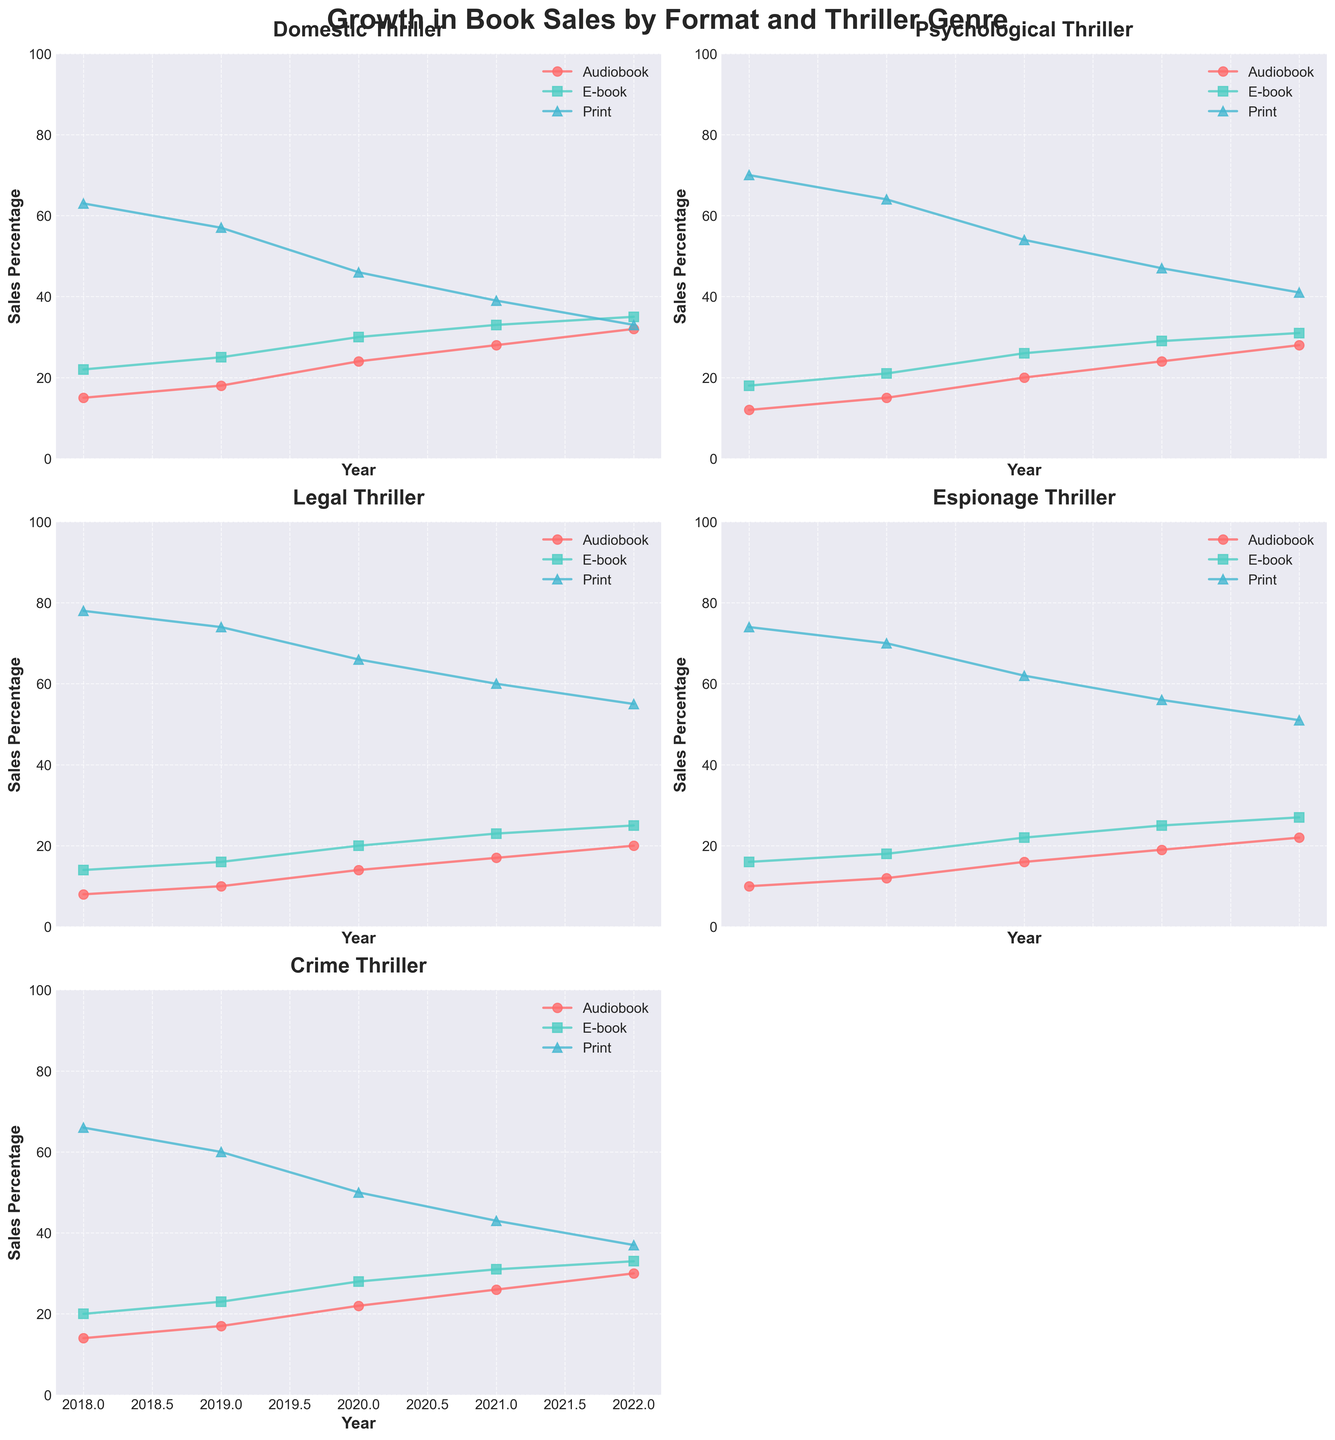What's the title of the figure? The title is displayed at the top of the figure and often indicates the main theme or focus of the figure. In this case, the title helps understand that the figure is about the growth in book sales by format and thriller genre over a period.
Answer: Growth in Book Sales by Format and Thriller Genre How many thriller subgenres are displayed? Each subplot represents a different thriller subgenre. By counting the subplots, we can determine the number of thriller subgenres visualized.
Answer: 5 What was the trend in audiobook sales for Domestic Thriller from 2018 to 2022? Looking at the line for audiobooks in the Domestic Thriller subplot, we start from the leftmost point at 2018 and follow it through to the rightmost point at 2022. The trend can be described as increasing, decreasing, or remaining constant.
Answer: Increasing Which format had the highest sales for Psychological Thriller in 2022? In the Psychological Thriller subplot, we compare the final points (2022) for each format (audiobook, e-book, and print). The format with the highest point on the y-axis represents the highest sales.
Answer: Print Between 2019 and 2020, which format saw the largest increase in sales for Legal Thriller? In the Legal Thriller subplot, we observe each format’s line segment from 2019 to 2020. The largest vertical jump (increase) indicates the format with the largest sales growth.
Answer: Audiobook Which subgenre had the steepest increase in e-book sales between 2018 and 2022? For each subplot, we observe the e-book line from 2018 to 2022. The steepest increase is identified by the sharpest upward angle.
Answer: Psychological Thriller In the Crime Thriller subplot, which year saw the most significant drop in print sales? We follow the print line in the Crime Thriller subplot and identify the year with the steepest decline. This indicates the year with the most significant drop in sales.
Answer: 2019 How did the print sales of Espionage Thriller change from 2018 to 2022? In the Espionage Thriller subplot, we observe the print line from 2018 to 2022. We note the overall trend by comparing the starting and ending points.
Answer: Decreasing What was the difference in e-book sales for Domestic Thriller between 2018 and 2022? In the Domestic Thriller subplot, find the e-book sales values for 2018 and 2022 and subtract the 2018 value from the 2022 value to find the difference.
Answer: 13 Which format had consistent growth across all subgenres over the 5 years? We need to look at each subplot and observe the general trend for each format’s line over the five years. Consistent growth means the line steadily increases without significant drops.
Answer: Audiobook 